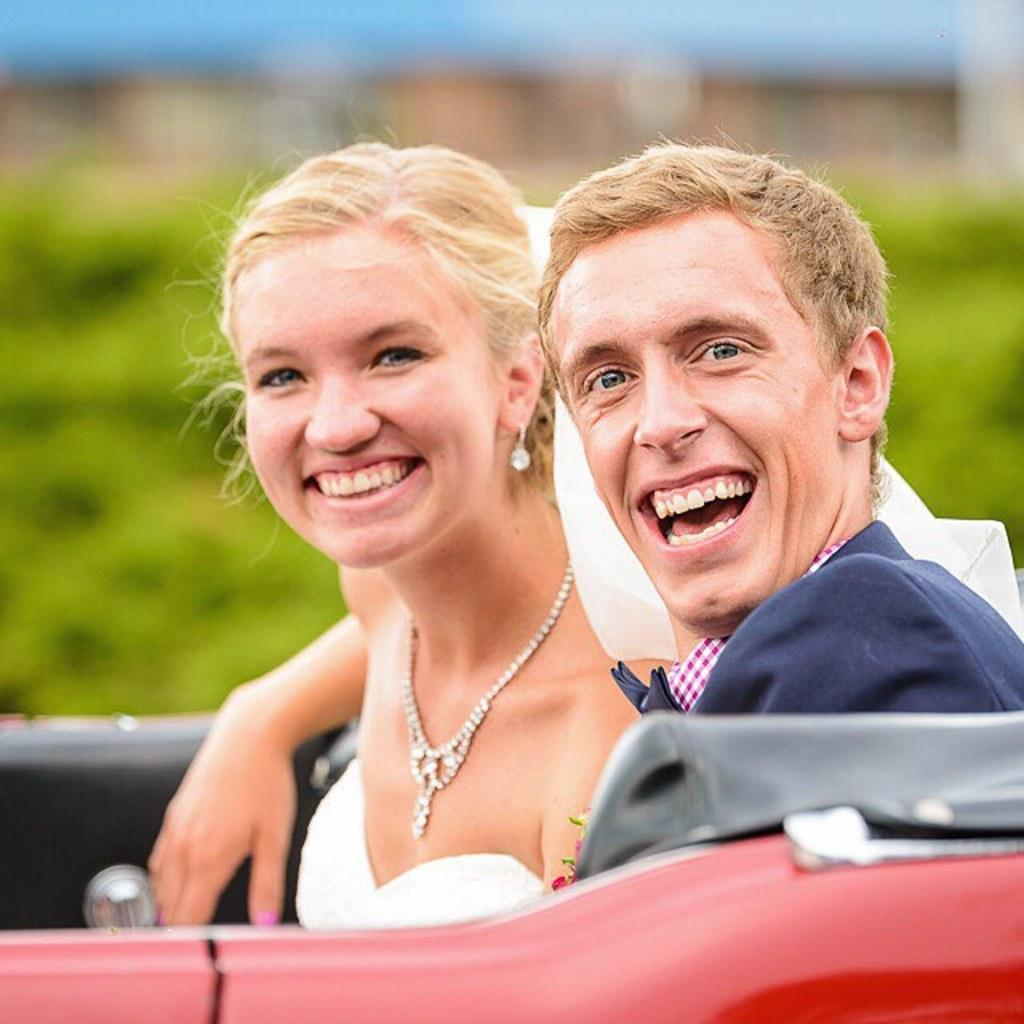Who is present in the image? There is a couple in the image. What are they doing in the image? The couple is sitting in a vehicle. What accessories is the woman wearing in the image? The woman is wearing a necklace and earrings in the image. What color are the eyes of the earth in the image? The image does not contain any representation of the earth, and therefore there are no eyes to describe. 